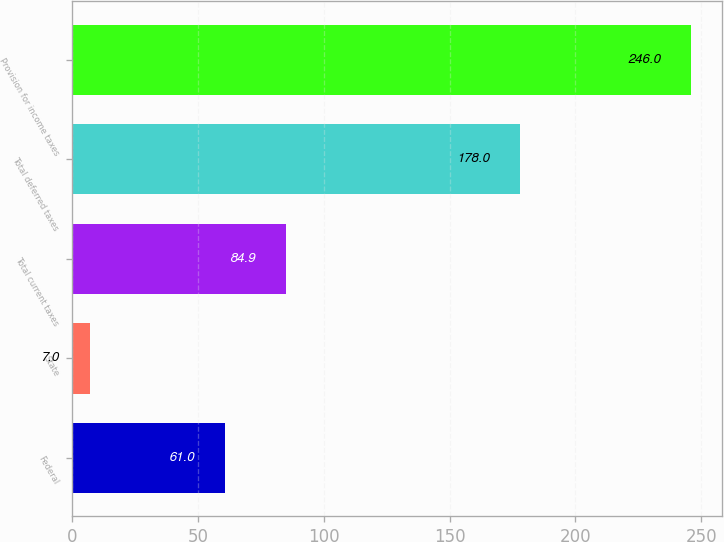Convert chart. <chart><loc_0><loc_0><loc_500><loc_500><bar_chart><fcel>Federal<fcel>State<fcel>Total current taxes<fcel>Total deferred taxes<fcel>Provision for income taxes<nl><fcel>61<fcel>7<fcel>84.9<fcel>178<fcel>246<nl></chart> 